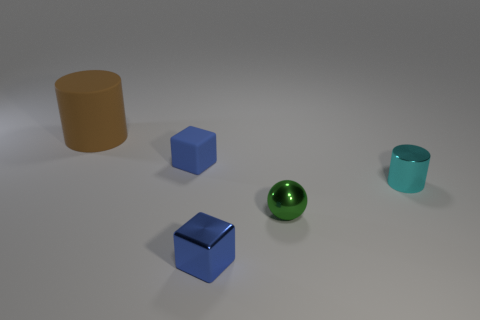Add 2 brown cylinders. How many brown cylinders are left? 3 Add 2 large green cubes. How many large green cubes exist? 2 Add 5 large red rubber spheres. How many objects exist? 10 Subtract 0 purple cubes. How many objects are left? 5 Subtract all cylinders. How many objects are left? 3 Subtract 2 blocks. How many blocks are left? 0 Subtract all cyan blocks. Subtract all cyan balls. How many blocks are left? 2 Subtract all purple blocks. How many brown cylinders are left? 1 Subtract all green metal things. Subtract all large cyan shiny blocks. How many objects are left? 4 